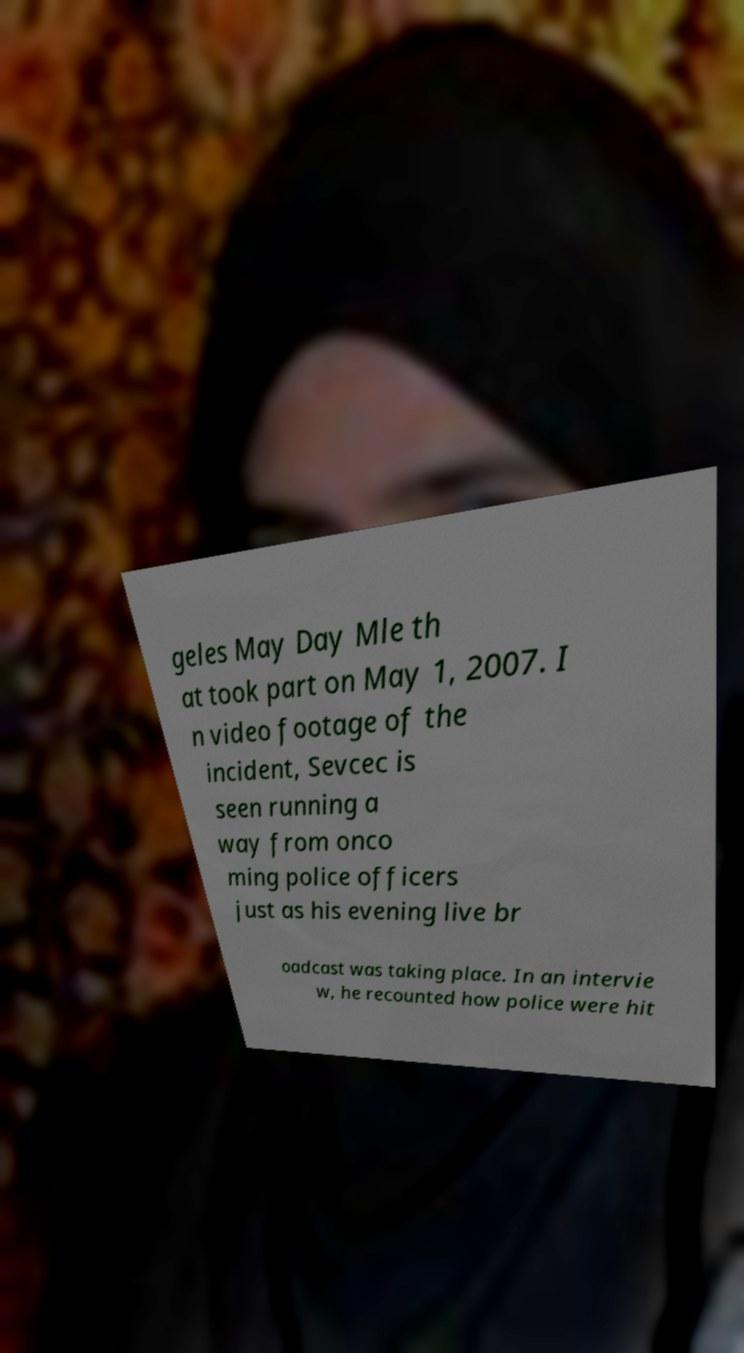Please read and relay the text visible in this image. What does it say? geles May Day Mle th at took part on May 1, 2007. I n video footage of the incident, Sevcec is seen running a way from onco ming police officers just as his evening live br oadcast was taking place. In an intervie w, he recounted how police were hit 